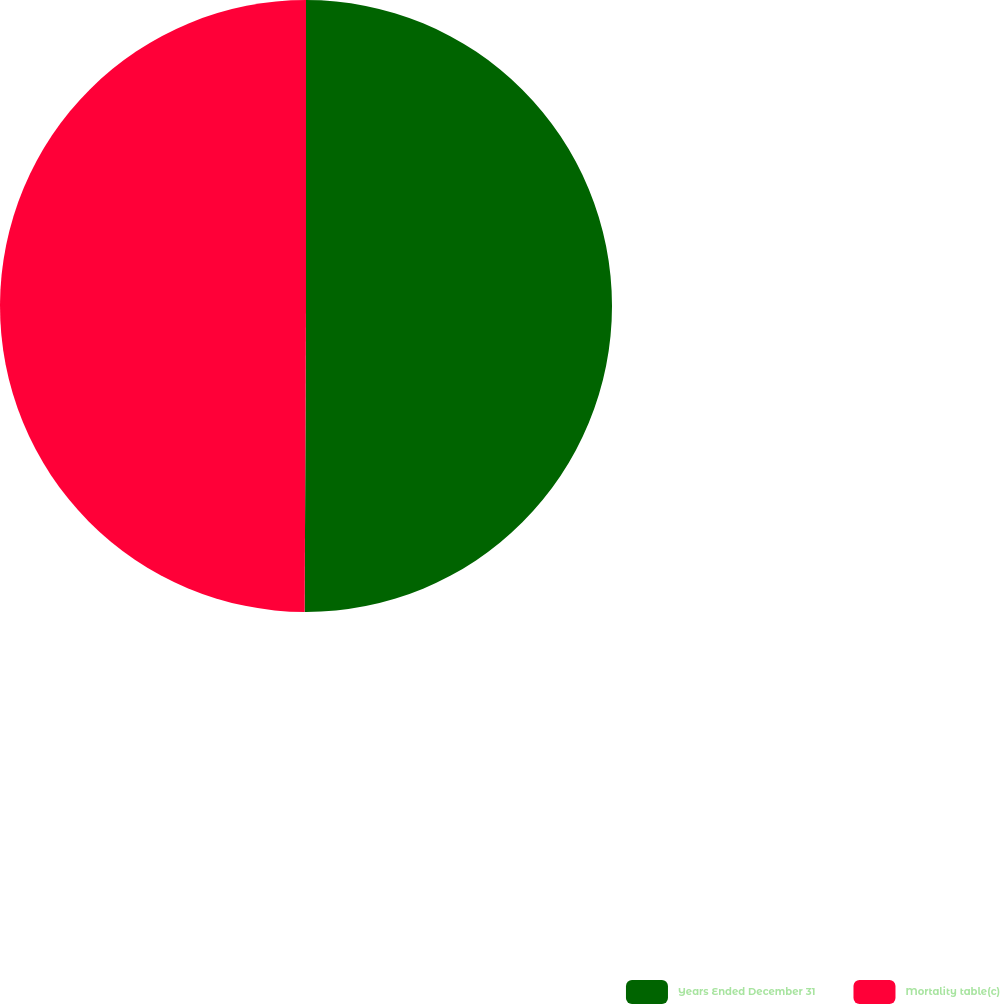Convert chart. <chart><loc_0><loc_0><loc_500><loc_500><pie_chart><fcel>Years Ended December 31<fcel>Mortality table(c)<nl><fcel>50.07%<fcel>49.93%<nl></chart> 